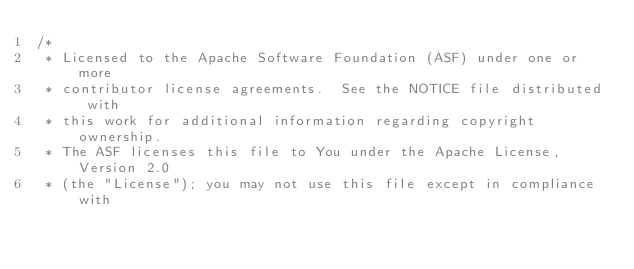<code> <loc_0><loc_0><loc_500><loc_500><_Java_>/*
 * Licensed to the Apache Software Foundation (ASF) under one or more
 * contributor license agreements.  See the NOTICE file distributed with
 * this work for additional information regarding copyright ownership.
 * The ASF licenses this file to You under the Apache License, Version 2.0
 * (the "License"); you may not use this file except in compliance with</code> 